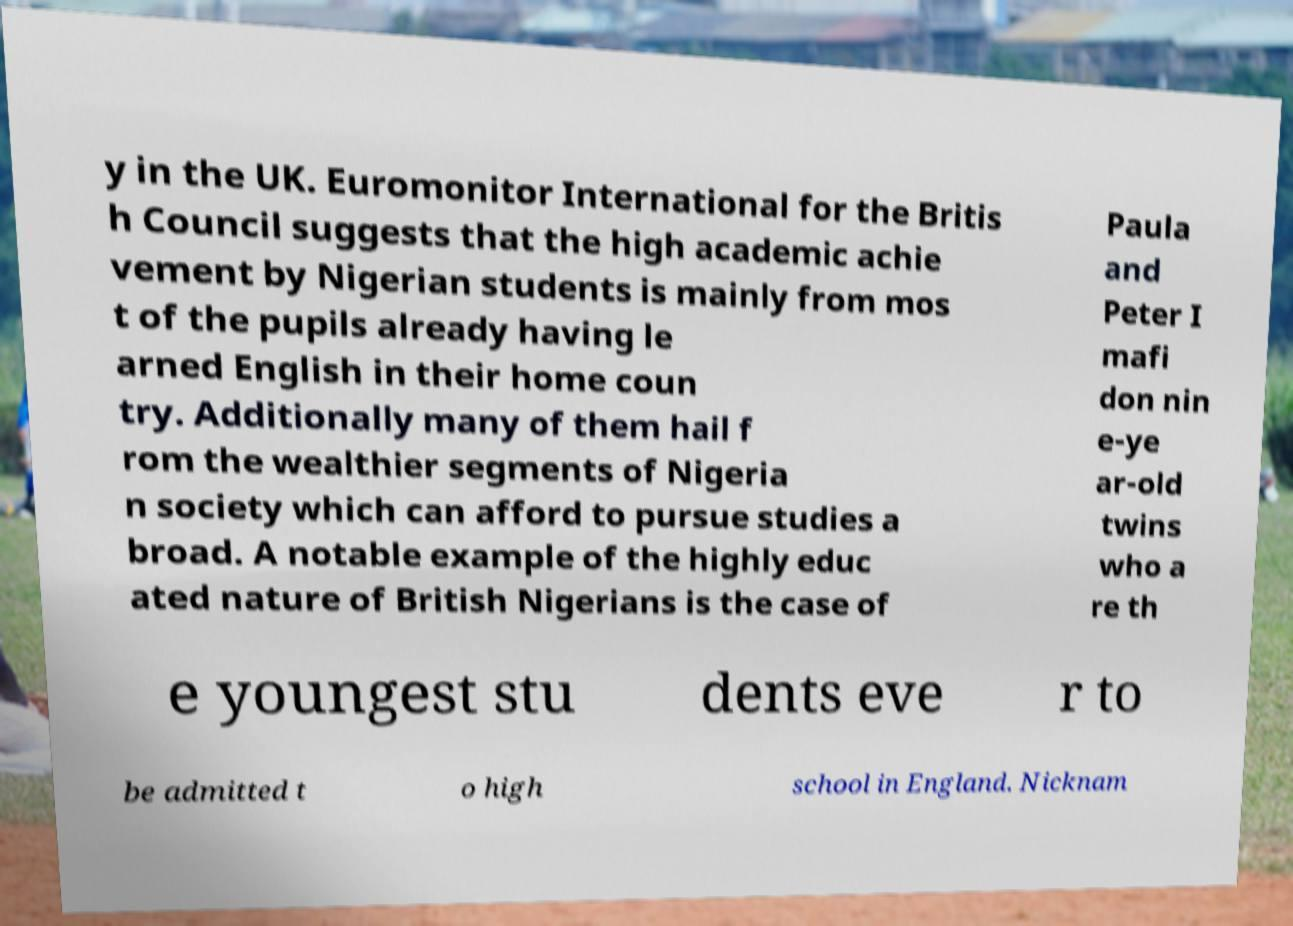What messages or text are displayed in this image? I need them in a readable, typed format. y in the UK. Euromonitor International for the Britis h Council suggests that the high academic achie vement by Nigerian students is mainly from mos t of the pupils already having le arned English in their home coun try. Additionally many of them hail f rom the wealthier segments of Nigeria n society which can afford to pursue studies a broad. A notable example of the highly educ ated nature of British Nigerians is the case of Paula and Peter I mafi don nin e-ye ar-old twins who a re th e youngest stu dents eve r to be admitted t o high school in England. Nicknam 